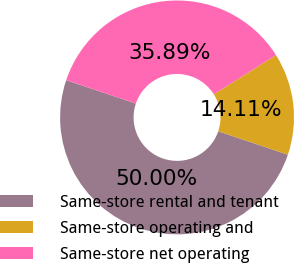Convert chart to OTSL. <chart><loc_0><loc_0><loc_500><loc_500><pie_chart><fcel>Same-store rental and tenant<fcel>Same-store operating and<fcel>Same-store net operating<nl><fcel>50.0%<fcel>14.11%<fcel>35.89%<nl></chart> 